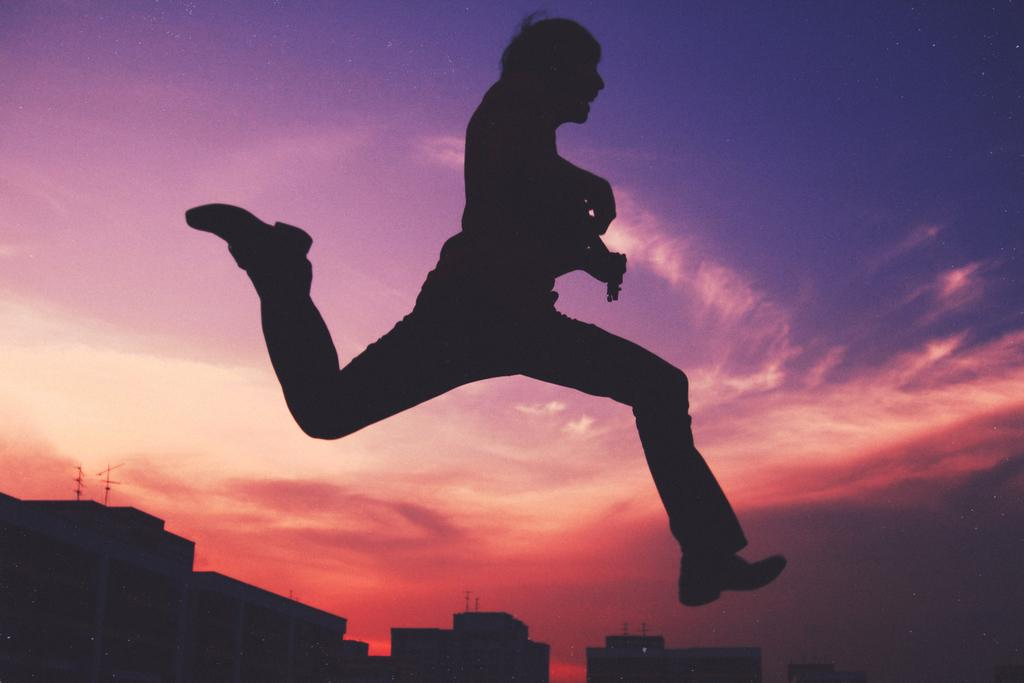What is the person in the image doing? The person is in the air, which suggests they might be flying or jumping. What is the person holding in the image? The person is holding an object, but the specific object is not mentioned in the facts. What can be seen at the bottom of the image? There are buildings at the bottom of the image. What is visible in the background of the image? The sky is visible in the background of the image. What type of bait is the person using to catch fish in the image? There is no mention of fishing or bait in the image, so it cannot be determined from the facts. 